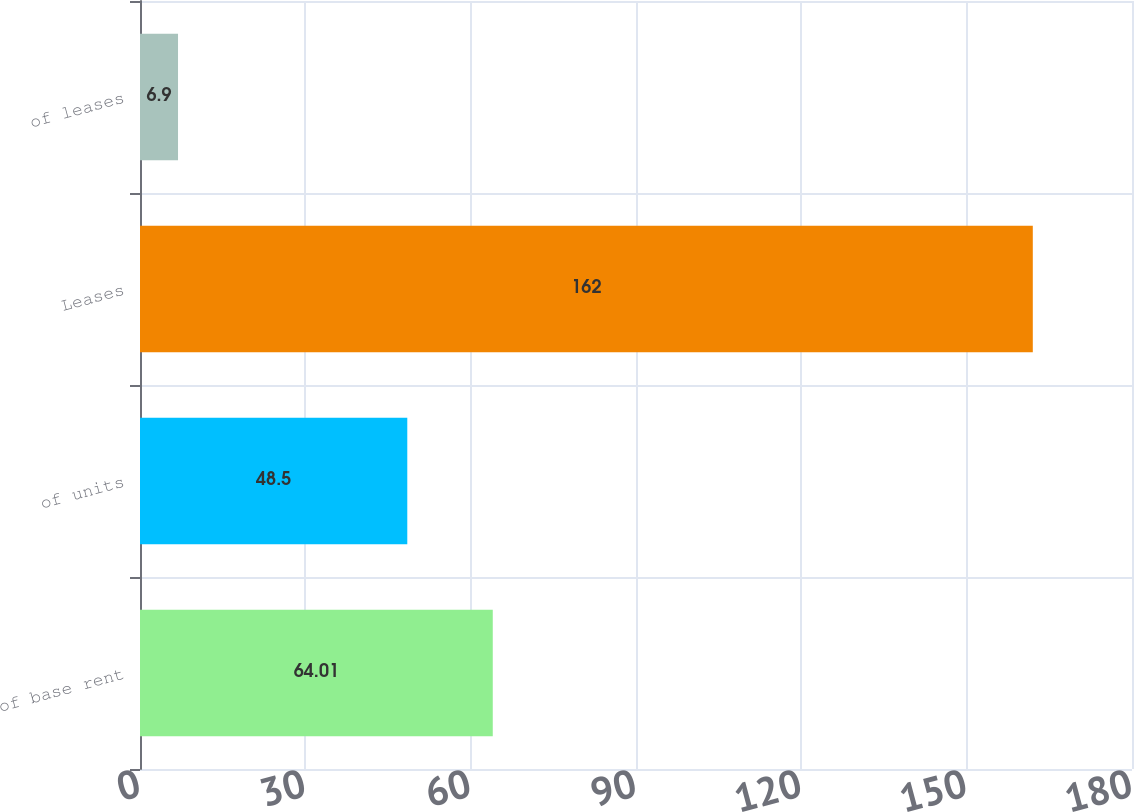Convert chart to OTSL. <chart><loc_0><loc_0><loc_500><loc_500><bar_chart><fcel>of base rent<fcel>of units<fcel>Leases<fcel>of leases<nl><fcel>64.01<fcel>48.5<fcel>162<fcel>6.9<nl></chart> 